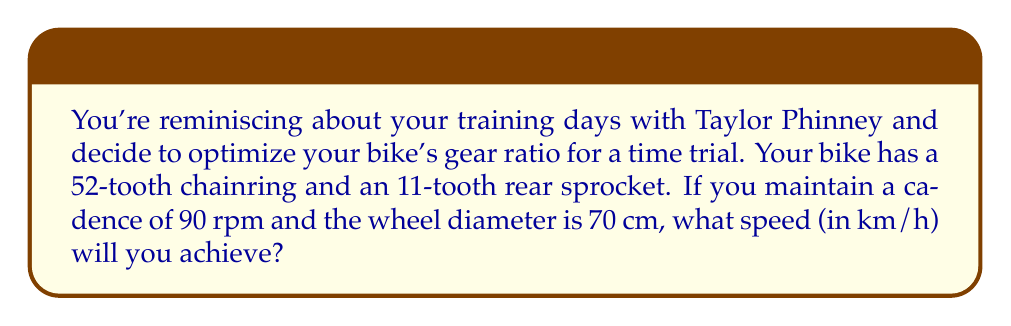Give your solution to this math problem. Let's approach this step-by-step:

1) First, we need to calculate the gear ratio:
   $$ \text{Gear Ratio} = \frac{\text{Number of teeth on chainring}}{\text{Number of teeth on rear sprocket}} = \frac{52}{11} = 4.73 $$

2) Now, let's calculate the distance traveled in one pedal revolution:
   $$ \text{Distance per revolution} = \pi \times \text{wheel diameter} \times \text{gear ratio} $$
   $$ = \pi \times 70 \text{ cm} \times 4.73 = 1038.95 \text{ cm} = 10.3895 \text{ m} $$

3) Given the cadence of 90 rpm, we can calculate the distance traveled per minute:
   $$ \text{Distance per minute} = 90 \times 10.3895 \text{ m} = 935.055 \text{ m} $$

4) To convert this to km/h:
   $$ \text{Speed} = 935.055 \text{ m/min} \times \frac{60 \text{ min}}{1 \text{ hour}} \times \frac{1 \text{ km}}{1000 \text{ m}} = 56.1033 \text{ km/h} $$

[asy]
size(200);
draw(circle((0,0),1));
draw((0,0)--(1,0),Arrow);
label("70 cm", (0.5,0), S);
draw((0,0)--(-0.7,0.7),Arrow);
label("Rotation", (-0.5,0.5), NW);
[/asy]
Answer: 56.1 km/h 